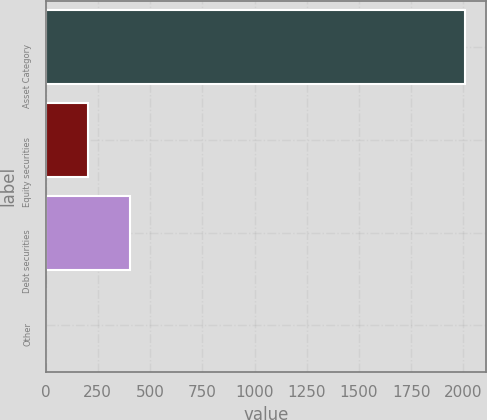Convert chart. <chart><loc_0><loc_0><loc_500><loc_500><bar_chart><fcel>Asset Category<fcel>Equity securities<fcel>Debt securities<fcel>Other<nl><fcel>2008<fcel>201.7<fcel>402.4<fcel>1<nl></chart> 